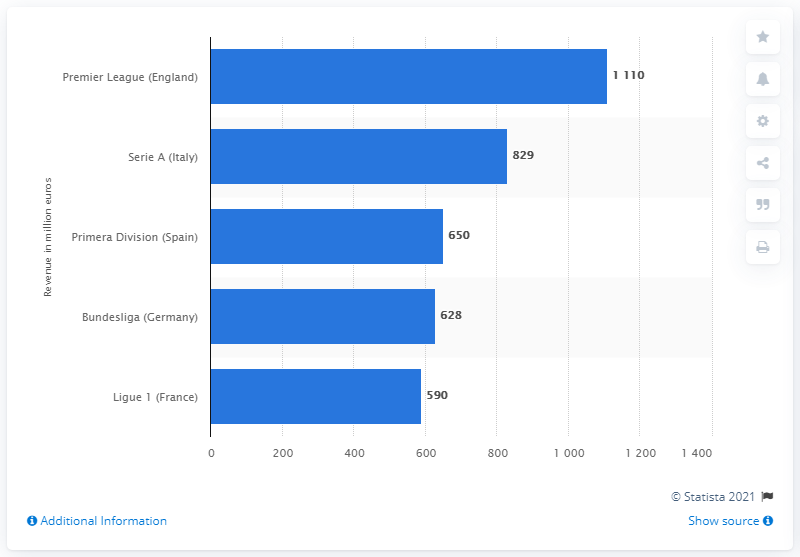Highlight a few significant elements in this photo. The English Premier League generates approximately 1110 million dollars per season from television marketing. 